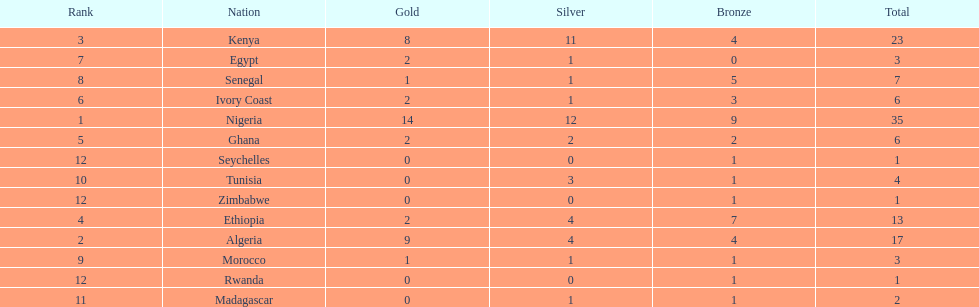Give me the full table as a dictionary. {'header': ['Rank', 'Nation', 'Gold', 'Silver', 'Bronze', 'Total'], 'rows': [['3', 'Kenya', '8', '11', '4', '23'], ['7', 'Egypt', '2', '1', '0', '3'], ['8', 'Senegal', '1', '1', '5', '7'], ['6', 'Ivory Coast', '2', '1', '3', '6'], ['1', 'Nigeria', '14', '12', '9', '35'], ['5', 'Ghana', '2', '2', '2', '6'], ['12', 'Seychelles', '0', '0', '1', '1'], ['10', 'Tunisia', '0', '3', '1', '4'], ['12', 'Zimbabwe', '0', '0', '1', '1'], ['4', 'Ethiopia', '2', '4', '7', '13'], ['2', 'Algeria', '9', '4', '4', '17'], ['9', 'Morocco', '1', '1', '1', '3'], ['12', 'Rwanda', '0', '0', '1', '1'], ['11', 'Madagascar', '0', '1', '1', '2']]} The team with the most gold medals Nigeria. 